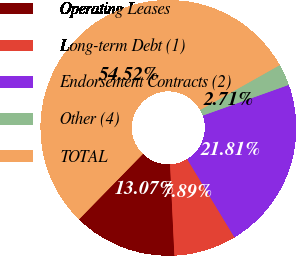<chart> <loc_0><loc_0><loc_500><loc_500><pie_chart><fcel>Operating Leases<fcel>Long-term Debt (1)<fcel>Endorsement Contracts (2)<fcel>Other (4)<fcel>TOTAL<nl><fcel>13.07%<fcel>7.89%<fcel>21.81%<fcel>2.71%<fcel>54.51%<nl></chart> 